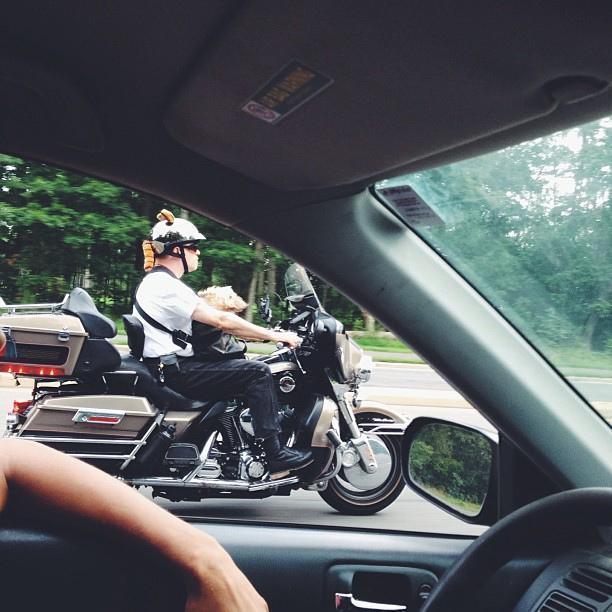How many people can be seen?
Give a very brief answer. 2. How many chairs are pictured at the table?
Give a very brief answer. 0. 